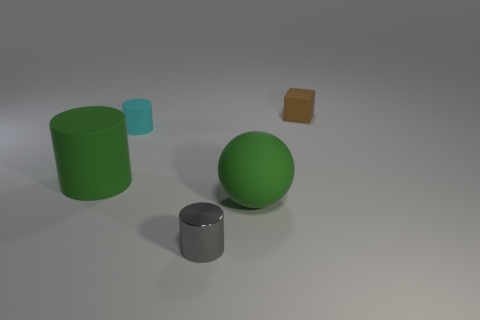Subtract all purple blocks. Subtract all red spheres. How many blocks are left? 1 Add 2 big gray shiny cylinders. How many objects exist? 7 Subtract all balls. How many objects are left? 4 Add 2 tiny objects. How many tiny objects are left? 5 Add 4 large gray things. How many large gray things exist? 4 Subtract 0 blue blocks. How many objects are left? 5 Subtract all tiny brown matte cubes. Subtract all cylinders. How many objects are left? 1 